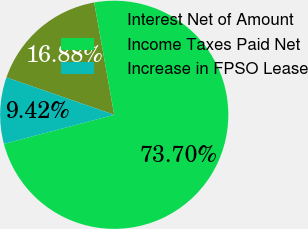Convert chart. <chart><loc_0><loc_0><loc_500><loc_500><pie_chart><fcel>Interest Net of Amount<fcel>Income Taxes Paid Net<fcel>Increase in FPSO Lease<nl><fcel>16.88%<fcel>73.7%<fcel>9.42%<nl></chart> 